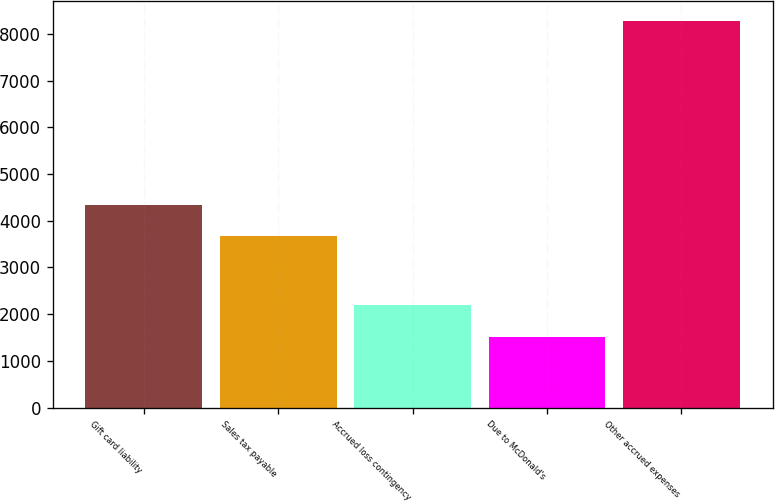Convert chart to OTSL. <chart><loc_0><loc_0><loc_500><loc_500><bar_chart><fcel>Gift card liability<fcel>Sales tax payable<fcel>Accrued loss contingency<fcel>Due to McDonald's<fcel>Other accrued expenses<nl><fcel>4343<fcel>3666<fcel>2191<fcel>1514<fcel>8284<nl></chart> 